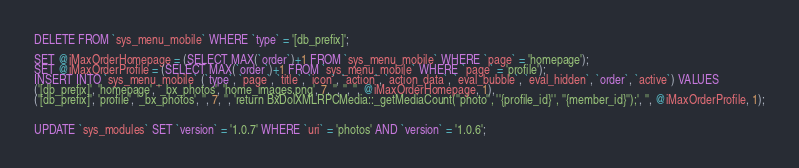<code> <loc_0><loc_0><loc_500><loc_500><_SQL_>
DELETE FROM `sys_menu_mobile` WHERE `type` = '[db_prefix]';

SET @iMaxOrderHomepage = (SELECT MAX(`order`)+1 FROM `sys_menu_mobile` WHERE `page` = 'homepage');
SET @iMaxOrderProfile = (SELECT MAX(`order`)+1 FROM `sys_menu_mobile` WHERE `page` = 'profile');
INSERT INTO `sys_menu_mobile` (`type`, `page`, `title`, `icon`, `action`, `action_data`, `eval_bubble`, `eval_hidden`, `order`, `active`) VALUES
('[db_prefix]', 'homepage', '_bx_photos', 'home_images.png', 7, '', '', '', @iMaxOrderHomepage, 1),
('[db_prefix]', 'profile', '_bx_photos', '', 7, '', 'return BxDolXMLRPCMedia::_getMediaCount(''photo'', ''{profile_id}'', ''{member_id}'');', '', @iMaxOrderProfile, 1);


UPDATE `sys_modules` SET `version` = '1.0.7' WHERE `uri` = 'photos' AND `version` = '1.0.6';

</code> 